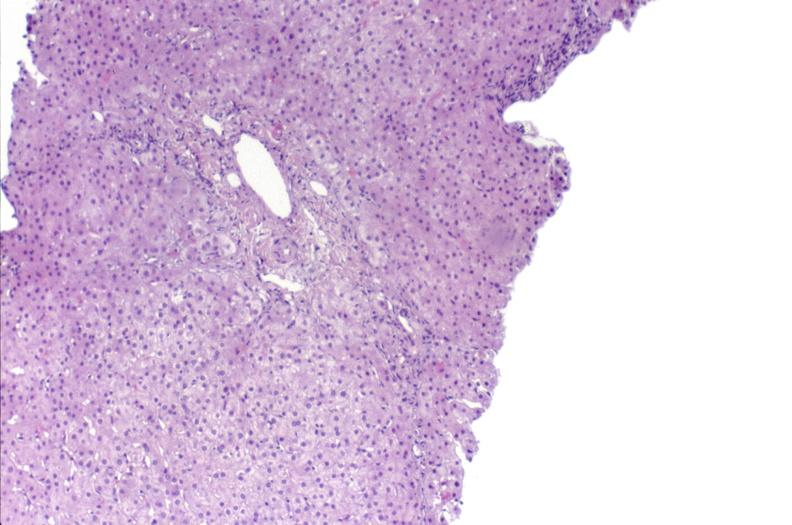what does this image show?
Answer the question using a single word or phrase. Ductopenia 